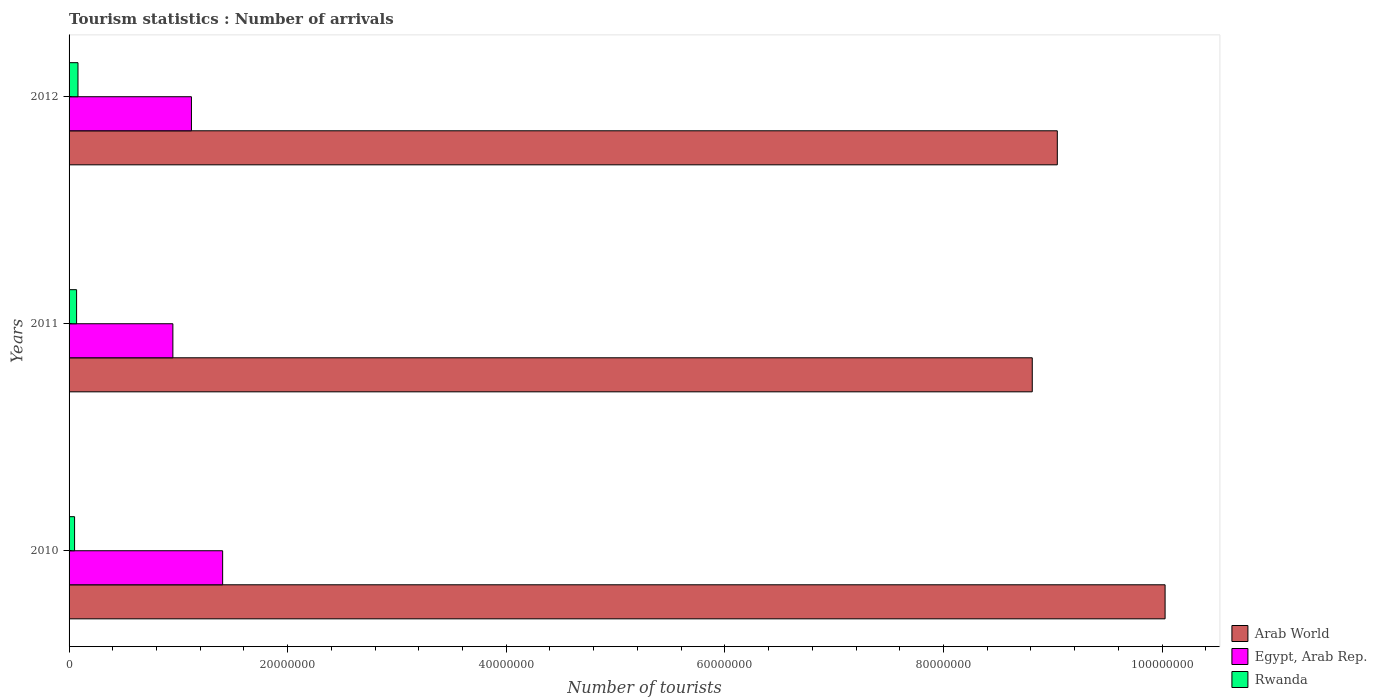How many different coloured bars are there?
Your answer should be very brief. 3. How many groups of bars are there?
Keep it short and to the point. 3. Are the number of bars per tick equal to the number of legend labels?
Your answer should be compact. Yes. Are the number of bars on each tick of the Y-axis equal?
Keep it short and to the point. Yes. How many bars are there on the 1st tick from the top?
Offer a very short reply. 3. How many bars are there on the 2nd tick from the bottom?
Offer a terse response. 3. What is the number of tourist arrivals in Arab World in 2011?
Your answer should be very brief. 8.81e+07. Across all years, what is the maximum number of tourist arrivals in Arab World?
Offer a terse response. 1.00e+08. Across all years, what is the minimum number of tourist arrivals in Arab World?
Your response must be concise. 8.81e+07. What is the total number of tourist arrivals in Egypt, Arab Rep. in the graph?
Your answer should be very brief. 3.47e+07. What is the difference between the number of tourist arrivals in Egypt, Arab Rep. in 2010 and that in 2012?
Your response must be concise. 2.86e+06. What is the difference between the number of tourist arrivals in Rwanda in 2010 and the number of tourist arrivals in Egypt, Arab Rep. in 2012?
Your response must be concise. -1.07e+07. What is the average number of tourist arrivals in Egypt, Arab Rep. per year?
Give a very brief answer. 1.16e+07. In the year 2010, what is the difference between the number of tourist arrivals in Egypt, Arab Rep. and number of tourist arrivals in Arab World?
Your answer should be very brief. -8.62e+07. In how many years, is the number of tourist arrivals in Arab World greater than 36000000 ?
Your answer should be compact. 3. What is the ratio of the number of tourist arrivals in Arab World in 2010 to that in 2012?
Your answer should be very brief. 1.11. Is the number of tourist arrivals in Arab World in 2011 less than that in 2012?
Ensure brevity in your answer.  Yes. Is the difference between the number of tourist arrivals in Egypt, Arab Rep. in 2011 and 2012 greater than the difference between the number of tourist arrivals in Arab World in 2011 and 2012?
Your answer should be very brief. Yes. What is the difference between the highest and the second highest number of tourist arrivals in Egypt, Arab Rep.?
Keep it short and to the point. 2.86e+06. What is the difference between the highest and the lowest number of tourist arrivals in Egypt, Arab Rep.?
Keep it short and to the point. 4.55e+06. In how many years, is the number of tourist arrivals in Arab World greater than the average number of tourist arrivals in Arab World taken over all years?
Provide a succinct answer. 1. Is the sum of the number of tourist arrivals in Rwanda in 2010 and 2012 greater than the maximum number of tourist arrivals in Arab World across all years?
Keep it short and to the point. No. What does the 1st bar from the top in 2012 represents?
Keep it short and to the point. Rwanda. What does the 2nd bar from the bottom in 2010 represents?
Your answer should be very brief. Egypt, Arab Rep. Is it the case that in every year, the sum of the number of tourist arrivals in Arab World and number of tourist arrivals in Egypt, Arab Rep. is greater than the number of tourist arrivals in Rwanda?
Give a very brief answer. Yes. How many bars are there?
Keep it short and to the point. 9. How many years are there in the graph?
Make the answer very short. 3. Are the values on the major ticks of X-axis written in scientific E-notation?
Keep it short and to the point. No. Does the graph contain grids?
Make the answer very short. No. How many legend labels are there?
Provide a succinct answer. 3. How are the legend labels stacked?
Provide a short and direct response. Vertical. What is the title of the graph?
Offer a very short reply. Tourism statistics : Number of arrivals. Does "Caribbean small states" appear as one of the legend labels in the graph?
Keep it short and to the point. No. What is the label or title of the X-axis?
Offer a terse response. Number of tourists. What is the Number of tourists in Arab World in 2010?
Make the answer very short. 1.00e+08. What is the Number of tourists in Egypt, Arab Rep. in 2010?
Give a very brief answer. 1.41e+07. What is the Number of tourists in Rwanda in 2010?
Keep it short and to the point. 5.04e+05. What is the Number of tourists in Arab World in 2011?
Provide a short and direct response. 8.81e+07. What is the Number of tourists in Egypt, Arab Rep. in 2011?
Your answer should be very brief. 9.50e+06. What is the Number of tourists of Rwanda in 2011?
Make the answer very short. 6.88e+05. What is the Number of tourists of Arab World in 2012?
Your answer should be compact. 9.04e+07. What is the Number of tourists in Egypt, Arab Rep. in 2012?
Provide a succinct answer. 1.12e+07. What is the Number of tourists in Rwanda in 2012?
Offer a terse response. 8.15e+05. Across all years, what is the maximum Number of tourists of Arab World?
Ensure brevity in your answer.  1.00e+08. Across all years, what is the maximum Number of tourists in Egypt, Arab Rep.?
Offer a very short reply. 1.41e+07. Across all years, what is the maximum Number of tourists of Rwanda?
Your response must be concise. 8.15e+05. Across all years, what is the minimum Number of tourists in Arab World?
Make the answer very short. 8.81e+07. Across all years, what is the minimum Number of tourists in Egypt, Arab Rep.?
Provide a succinct answer. 9.50e+06. Across all years, what is the minimum Number of tourists of Rwanda?
Offer a very short reply. 5.04e+05. What is the total Number of tourists in Arab World in the graph?
Provide a succinct answer. 2.79e+08. What is the total Number of tourists of Egypt, Arab Rep. in the graph?
Your answer should be very brief. 3.47e+07. What is the total Number of tourists of Rwanda in the graph?
Offer a terse response. 2.01e+06. What is the difference between the Number of tourists of Arab World in 2010 and that in 2011?
Give a very brief answer. 1.22e+07. What is the difference between the Number of tourists in Egypt, Arab Rep. in 2010 and that in 2011?
Provide a short and direct response. 4.55e+06. What is the difference between the Number of tourists of Rwanda in 2010 and that in 2011?
Your answer should be very brief. -1.84e+05. What is the difference between the Number of tourists of Arab World in 2010 and that in 2012?
Provide a short and direct response. 9.86e+06. What is the difference between the Number of tourists in Egypt, Arab Rep. in 2010 and that in 2012?
Ensure brevity in your answer.  2.86e+06. What is the difference between the Number of tourists in Rwanda in 2010 and that in 2012?
Provide a short and direct response. -3.11e+05. What is the difference between the Number of tourists in Arab World in 2011 and that in 2012?
Offer a very short reply. -2.29e+06. What is the difference between the Number of tourists in Egypt, Arab Rep. in 2011 and that in 2012?
Provide a succinct answer. -1.70e+06. What is the difference between the Number of tourists in Rwanda in 2011 and that in 2012?
Provide a succinct answer. -1.27e+05. What is the difference between the Number of tourists in Arab World in 2010 and the Number of tourists in Egypt, Arab Rep. in 2011?
Offer a terse response. 9.08e+07. What is the difference between the Number of tourists in Arab World in 2010 and the Number of tourists in Rwanda in 2011?
Your answer should be compact. 9.96e+07. What is the difference between the Number of tourists of Egypt, Arab Rep. in 2010 and the Number of tourists of Rwanda in 2011?
Your answer should be compact. 1.34e+07. What is the difference between the Number of tourists of Arab World in 2010 and the Number of tourists of Egypt, Arab Rep. in 2012?
Your answer should be compact. 8.91e+07. What is the difference between the Number of tourists of Arab World in 2010 and the Number of tourists of Rwanda in 2012?
Provide a succinct answer. 9.95e+07. What is the difference between the Number of tourists in Egypt, Arab Rep. in 2010 and the Number of tourists in Rwanda in 2012?
Provide a succinct answer. 1.32e+07. What is the difference between the Number of tourists in Arab World in 2011 and the Number of tourists in Egypt, Arab Rep. in 2012?
Provide a short and direct response. 7.69e+07. What is the difference between the Number of tourists in Arab World in 2011 and the Number of tourists in Rwanda in 2012?
Your response must be concise. 8.73e+07. What is the difference between the Number of tourists of Egypt, Arab Rep. in 2011 and the Number of tourists of Rwanda in 2012?
Provide a short and direct response. 8.68e+06. What is the average Number of tourists in Arab World per year?
Your response must be concise. 9.29e+07. What is the average Number of tourists of Egypt, Arab Rep. per year?
Provide a succinct answer. 1.16e+07. What is the average Number of tourists of Rwanda per year?
Your answer should be compact. 6.69e+05. In the year 2010, what is the difference between the Number of tourists in Arab World and Number of tourists in Egypt, Arab Rep.?
Your answer should be compact. 8.62e+07. In the year 2010, what is the difference between the Number of tourists in Arab World and Number of tourists in Rwanda?
Offer a very short reply. 9.98e+07. In the year 2010, what is the difference between the Number of tourists in Egypt, Arab Rep. and Number of tourists in Rwanda?
Your response must be concise. 1.35e+07. In the year 2011, what is the difference between the Number of tourists in Arab World and Number of tourists in Egypt, Arab Rep.?
Your answer should be compact. 7.86e+07. In the year 2011, what is the difference between the Number of tourists in Arab World and Number of tourists in Rwanda?
Offer a terse response. 8.74e+07. In the year 2011, what is the difference between the Number of tourists in Egypt, Arab Rep. and Number of tourists in Rwanda?
Provide a succinct answer. 8.81e+06. In the year 2012, what is the difference between the Number of tourists of Arab World and Number of tourists of Egypt, Arab Rep.?
Provide a succinct answer. 7.92e+07. In the year 2012, what is the difference between the Number of tourists in Arab World and Number of tourists in Rwanda?
Make the answer very short. 8.96e+07. In the year 2012, what is the difference between the Number of tourists of Egypt, Arab Rep. and Number of tourists of Rwanda?
Provide a succinct answer. 1.04e+07. What is the ratio of the Number of tourists of Arab World in 2010 to that in 2011?
Give a very brief answer. 1.14. What is the ratio of the Number of tourists of Egypt, Arab Rep. in 2010 to that in 2011?
Keep it short and to the point. 1.48. What is the ratio of the Number of tourists in Rwanda in 2010 to that in 2011?
Make the answer very short. 0.73. What is the ratio of the Number of tourists in Arab World in 2010 to that in 2012?
Your response must be concise. 1.11. What is the ratio of the Number of tourists of Egypt, Arab Rep. in 2010 to that in 2012?
Keep it short and to the point. 1.25. What is the ratio of the Number of tourists in Rwanda in 2010 to that in 2012?
Keep it short and to the point. 0.62. What is the ratio of the Number of tourists in Arab World in 2011 to that in 2012?
Provide a short and direct response. 0.97. What is the ratio of the Number of tourists in Egypt, Arab Rep. in 2011 to that in 2012?
Your answer should be compact. 0.85. What is the ratio of the Number of tourists of Rwanda in 2011 to that in 2012?
Ensure brevity in your answer.  0.84. What is the difference between the highest and the second highest Number of tourists in Arab World?
Your response must be concise. 9.86e+06. What is the difference between the highest and the second highest Number of tourists of Egypt, Arab Rep.?
Provide a succinct answer. 2.86e+06. What is the difference between the highest and the second highest Number of tourists in Rwanda?
Your response must be concise. 1.27e+05. What is the difference between the highest and the lowest Number of tourists of Arab World?
Ensure brevity in your answer.  1.22e+07. What is the difference between the highest and the lowest Number of tourists in Egypt, Arab Rep.?
Provide a short and direct response. 4.55e+06. What is the difference between the highest and the lowest Number of tourists in Rwanda?
Keep it short and to the point. 3.11e+05. 